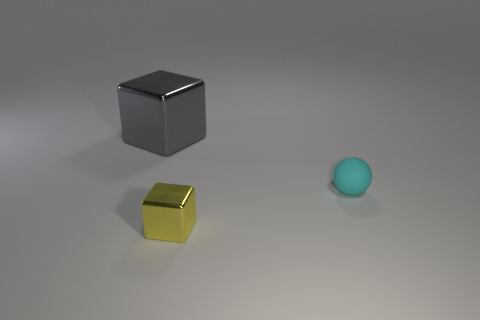Subtract all gray blocks. How many blocks are left? 1 Subtract all blocks. How many objects are left? 1 Subtract 1 blocks. How many blocks are left? 1 Add 2 tiny yellow metal objects. How many tiny yellow metal objects exist? 3 Add 1 small metal blocks. How many objects exist? 4 Subtract 0 purple blocks. How many objects are left? 3 Subtract all green cubes. Subtract all red spheres. How many cubes are left? 2 Subtract all blue blocks. How many yellow balls are left? 0 Subtract all gray shiny things. Subtract all tiny matte spheres. How many objects are left? 1 Add 2 tiny cyan balls. How many tiny cyan balls are left? 3 